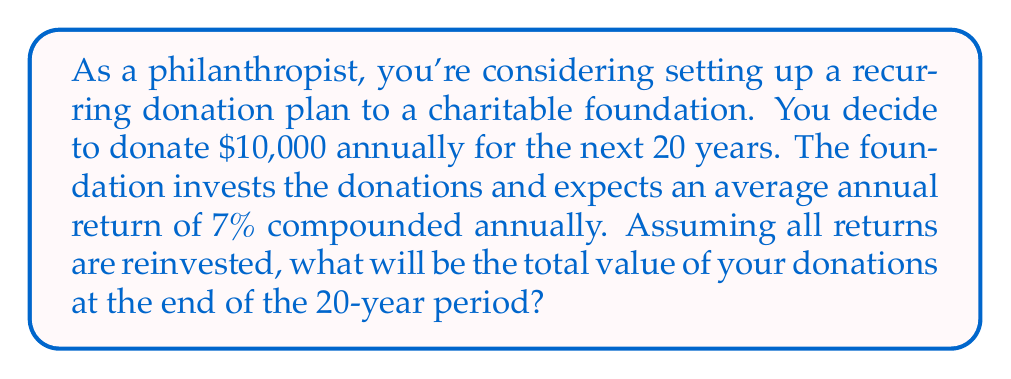Teach me how to tackle this problem. To solve this problem, we need to use the formula for the future value of an annuity, as we're dealing with recurring payments (donations) that grow with compound interest. The formula is:

$$FV = PMT \times \frac{(1+r)^n - 1}{r}$$

Where:
$FV$ = Future Value
$PMT$ = Regular Payment (Annual Donation)
$r$ = Annual Interest Rate
$n$ = Number of Years

Given:
$PMT = \$10,000$
$r = 7\% = 0.07$
$n = 20$ years

Let's substitute these values into the formula:

$$FV = 10,000 \times \frac{(1+0.07)^{20} - 1}{0.07}$$

Now, let's solve step by step:

1) First, calculate $(1+0.07)^{20}$:
   $(1.07)^{20} \approx 3.8697$

2) Subtract 1:
   $3.8697 - 1 = 2.8697$

3) Divide by 0.07:
   $\frac{2.8697}{0.07} \approx 40.9957$

4) Multiply by 10,000:
   $10,000 \times 40.9957 = 409,957$

Therefore, the future value of your donations after 20 years will be approximately $409,957.
Answer: $409,957 